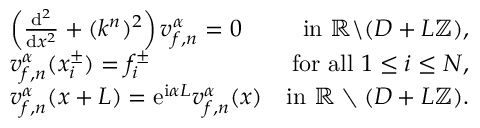<formula> <loc_0><loc_0><loc_500><loc_500>\begin{array} { r l r } & { \left ( \frac { d ^ { 2 } } { d x ^ { 2 } } + ( k ^ { n } ) ^ { 2 } \right ) v _ { f , n } ^ { \alpha } = 0 } & { i n \mathbb { R } \ ( D + L \mathbb { Z } ) , } \\ & { v _ { f , n } ^ { \alpha } ( x _ { i } ^ { \pm } ) = f _ { i } ^ { \pm } } & { f o r a l l 1 \leq i \leq N , } \\ & { v _ { f , n } ^ { \alpha } ( x + L ) = e ^ { i \alpha L } v _ { f , n } ^ { \alpha } ( x ) } & { i n \mathbb { R } \ ( D + L \mathbb { Z } ) . } \end{array}</formula> 